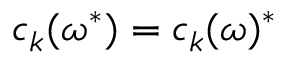<formula> <loc_0><loc_0><loc_500><loc_500>c _ { k } ( \omega ^ { * } ) = c _ { k } ( \omega ) ^ { * }</formula> 